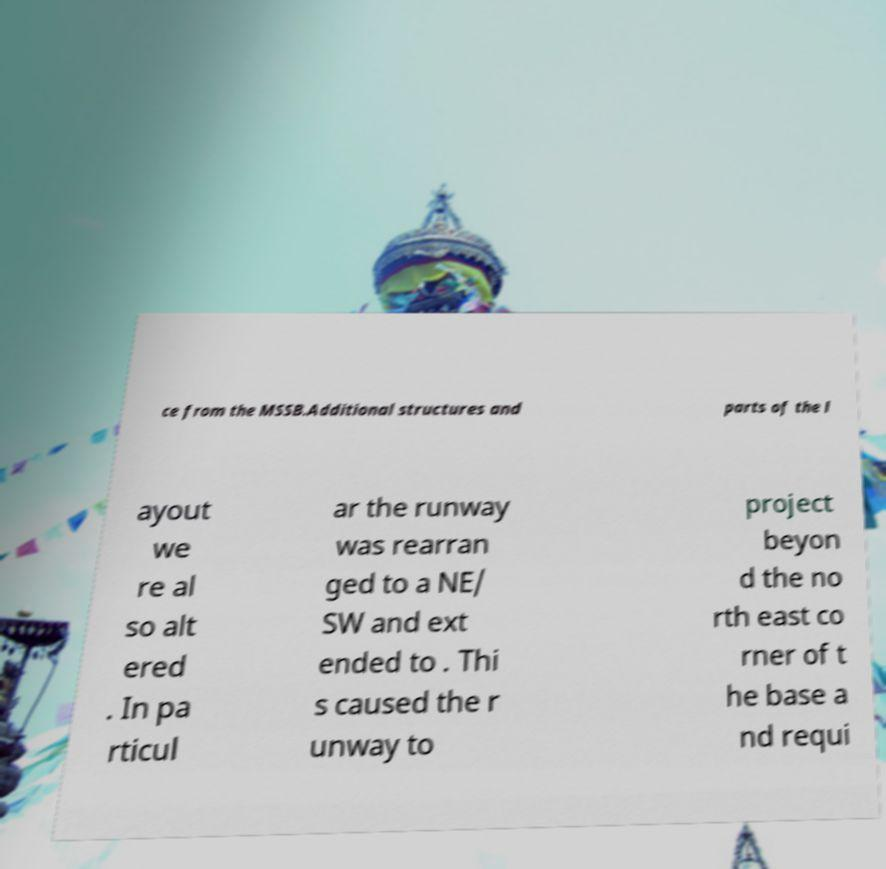Can you accurately transcribe the text from the provided image for me? ce from the MSSB.Additional structures and parts of the l ayout we re al so alt ered . In pa rticul ar the runway was rearran ged to a NE/ SW and ext ended to . Thi s caused the r unway to project beyon d the no rth east co rner of t he base a nd requi 